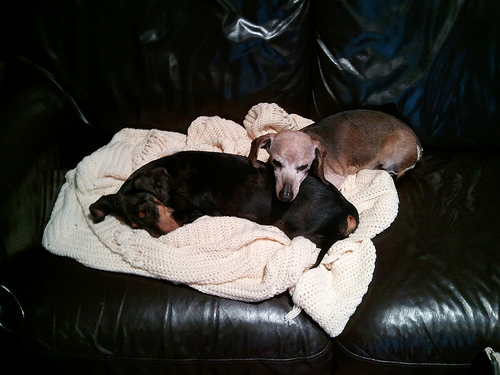<image>
Can you confirm if the dog is on the dog? Yes. Looking at the image, I can see the dog is positioned on top of the dog, with the dog providing support. 